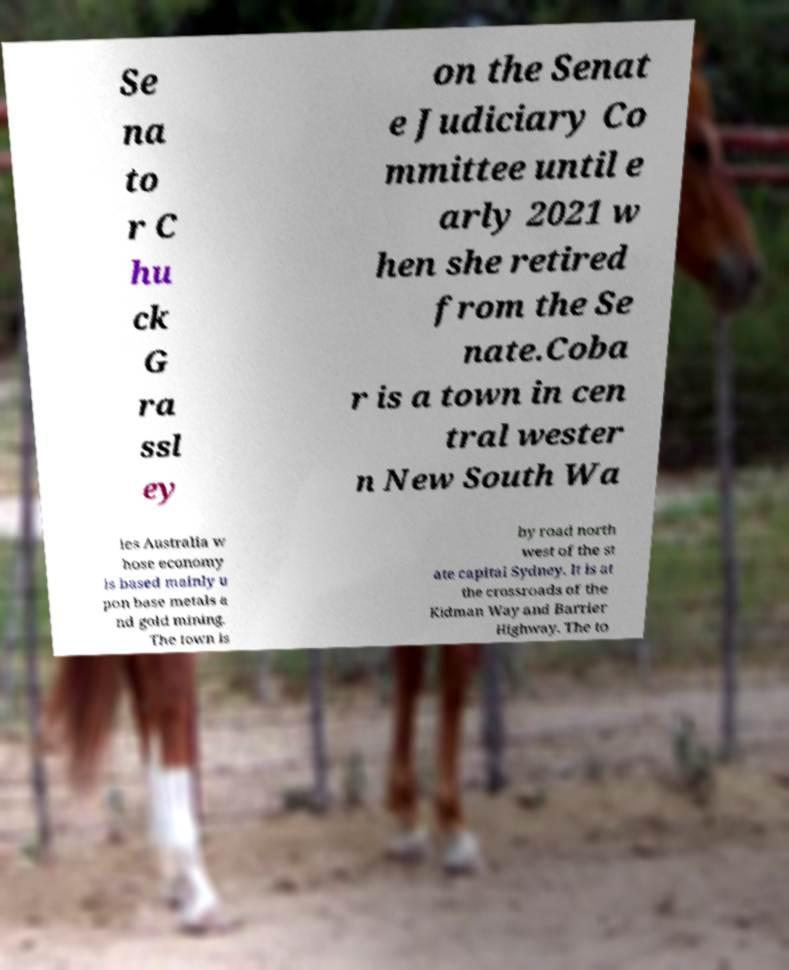What messages or text are displayed in this image? I need them in a readable, typed format. Se na to r C hu ck G ra ssl ey on the Senat e Judiciary Co mmittee until e arly 2021 w hen she retired from the Se nate.Coba r is a town in cen tral wester n New South Wa les Australia w hose economy is based mainly u pon base metals a nd gold mining. The town is by road north west of the st ate capital Sydney. It is at the crossroads of the Kidman Way and Barrier Highway. The to 